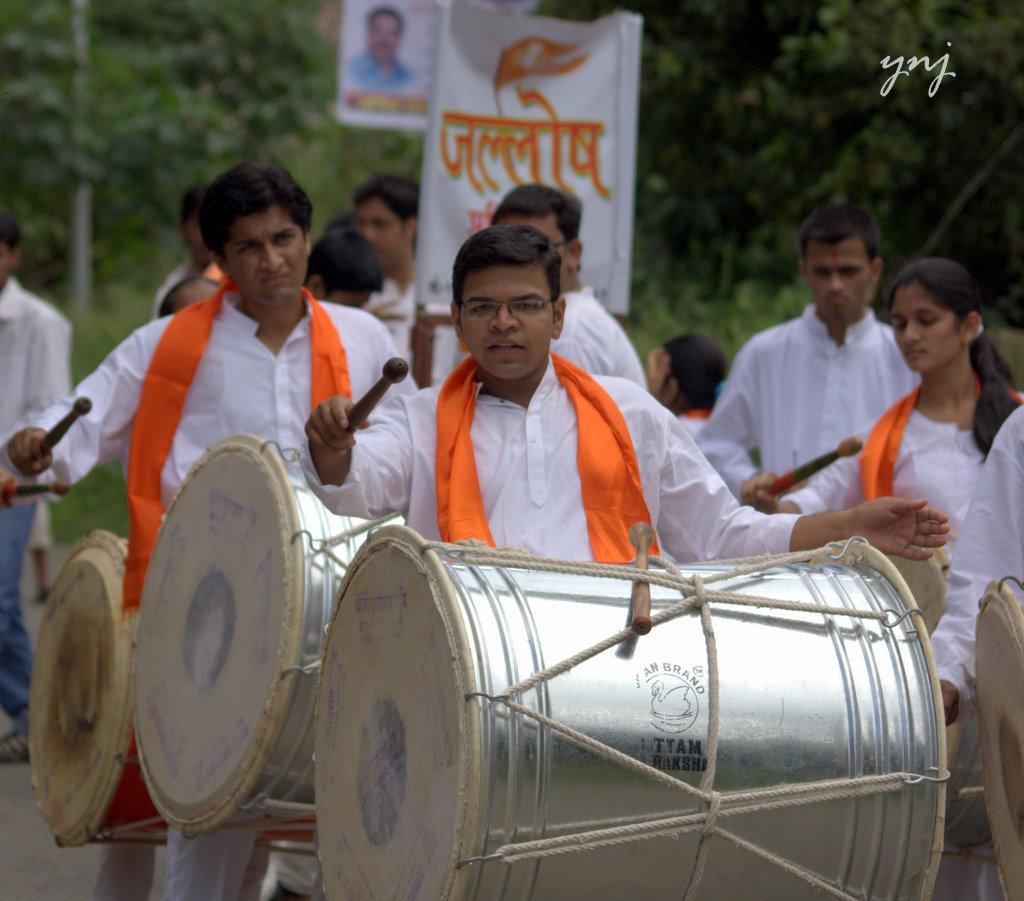What are the persons in the image doing? The persons in the image are holding drums and playing them with a stick. How are the drums being played in the image? The persons are playing the drums with a stick. What can be seen in the background of the image? Trees are present in the background of the image. What else is visible in the image besides the persons and drums? There is a banner visible in the image. How many icicles are hanging from the drums in the image? There are no icicles present in the image; it features persons playing drums with a stick. What type of copy is being made on the banner in the image? There is no copy being made on the banner in the image; it is already visible and does not involve any writing or duplication process. 